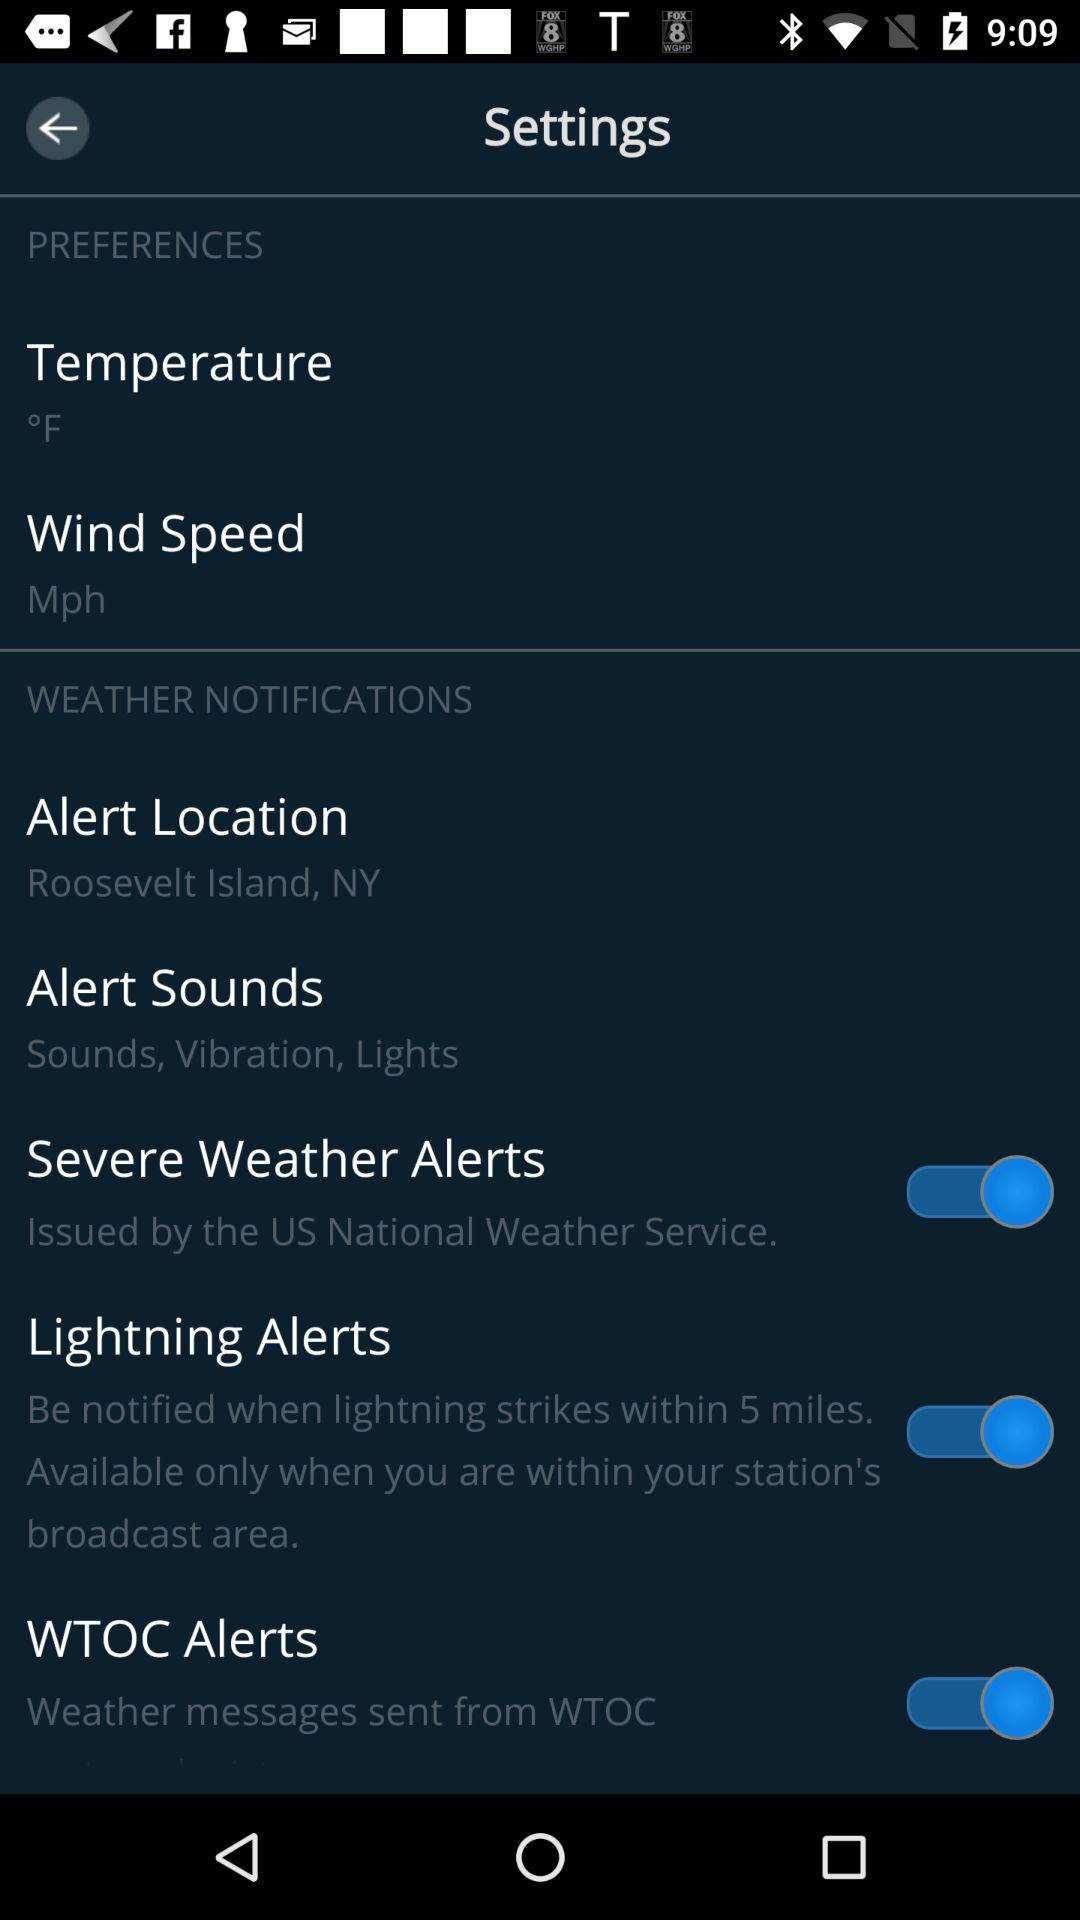In what city is the alert location? The alert location is for Roosevelt Island, NY. 